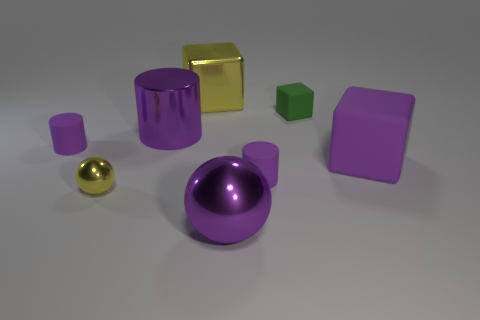Add 1 small purple spheres. How many objects exist? 9 Subtract all cylinders. How many objects are left? 5 Add 7 big blue matte cylinders. How many big blue matte cylinders exist? 7 Subtract 1 purple balls. How many objects are left? 7 Subtract all rubber cylinders. Subtract all yellow balls. How many objects are left? 5 Add 4 large purple matte objects. How many large purple matte objects are left? 5 